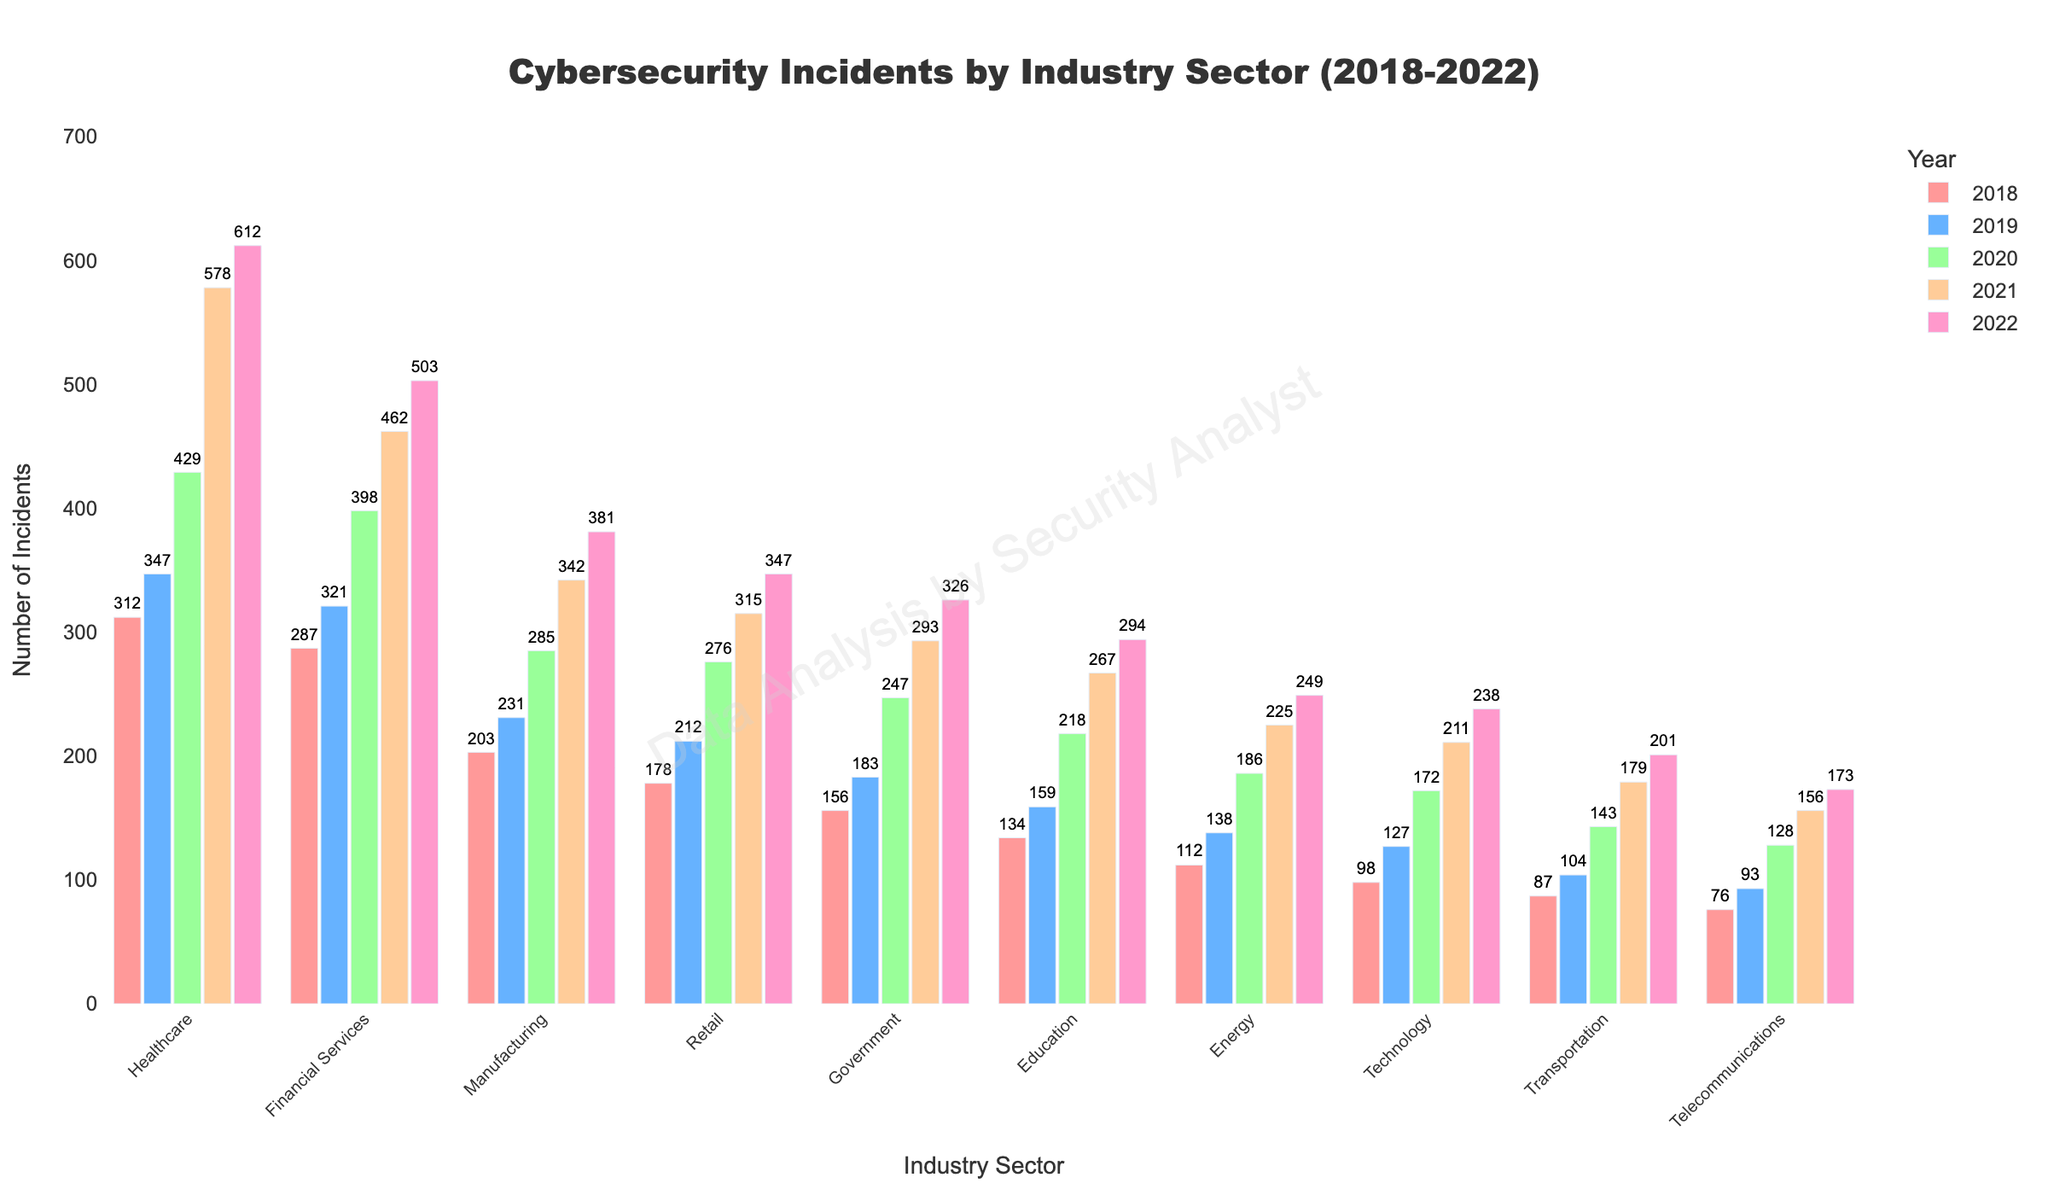what is the total number of incidents reported by the Healthcare sector in all five years? Sum the numbers of incidents reported by the Healthcare sector from 2018 to 2022: 312 + 347 + 429 + 578 + 612
Answer: 2278 Which industry sector had the highest number of incidents in 2022? Look at the heights of the bars for the year 2022 across all industry sectors and identify the tallest one, which is Healthcare.
Answer: Healthcare How did the number of incidents in the Financial Services sector change from 2018 to 2022? Calculate the difference between the number of incidents in 2022 (503) and 2018 (287) for the Financial Services sector.
Answer: Increased by 216 Which two sectors had the smallest and the largest increase in the number of incidents from 2018 to 2022? Subtract the number of incidents in 2018 from the number of incidents in 2022 for each sector. The Technology sector had the smallest increase (238 - 98 = 140) and Healthcare had the largest increase (612 - 312 = 300).
Answer: Smallest: Technology, Largest: Healthcare Are there any sectors where the number of incidents more than doubled from 2018 to 2022? Compare the number of incidents in 2022 with twice the number of incidents in 2018 for each sector. Healthcare (612 > 2*312), Financial Services (503 > 2*287), Retail (347 > 2*178), and others meet this criterion.
Answer: Yes, multiple sectors including Healthcare and Retail How do the number of incidents in the Transportation and Telecommunications sectors in 2022 compare? Compare the heights of the bars for the year 2022 in the Transportation (201 incidents) and Telecommunications sectors (173 incidents).
Answer: Transportation sector had more incidents What is the average number of incidents per year in the Energy sector over the period 2018-2022? Calculate the average by summing the incidents from 2018 to 2022 and dividing by 5. (112 + 138 + 186 + 225 + 249) / 5 = 182
Answer: 182 Which year saw the largest increase in incidents for the Retail sector, and what was the increase? Calculate the differences between consecutive years for the Retail sector and identify the largest: the largest increase occurred between 2019 and 2020 (276 - 212 = 64).
Answer: 2020, Increase of 64 Which sector showed the steadiest increase in incidents over the five years? Examine the height of the bars for each sector over the five years to identify which one increases consistently and steadily. Manufacturing and Financial Services show steady increases.
Answer: Manufacturing (or Financial Services) What is the combined number of incidents reported in 2020 for the Healthcare and Education sectors? Sum the number of incidents reported by Healthcare and Education sectors in 2020: 429 (Healthcare) + 218 (Education) = 647
Answer: 647 